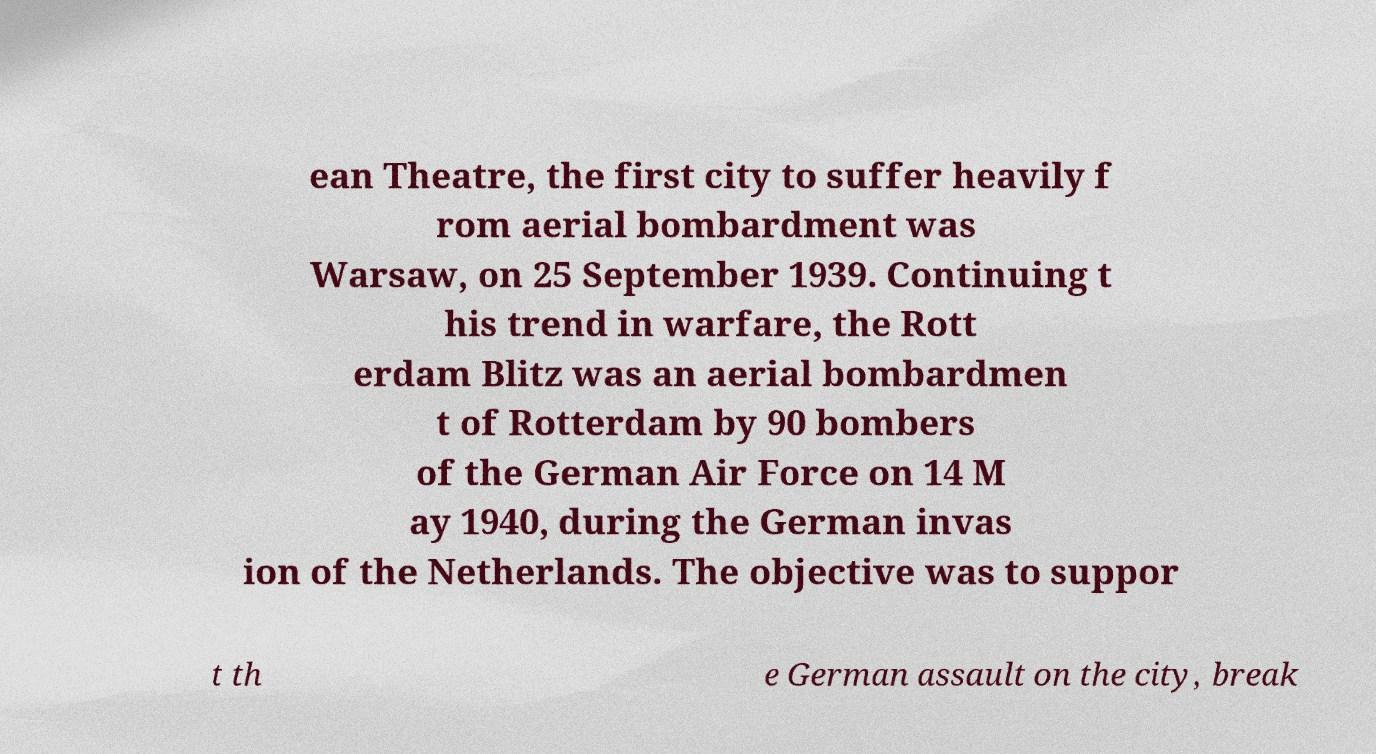Please identify and transcribe the text found in this image. ean Theatre, the first city to suffer heavily f rom aerial bombardment was Warsaw, on 25 September 1939. Continuing t his trend in warfare, the Rott erdam Blitz was an aerial bombardmen t of Rotterdam by 90 bombers of the German Air Force on 14 M ay 1940, during the German invas ion of the Netherlands. The objective was to suppor t th e German assault on the city, break 